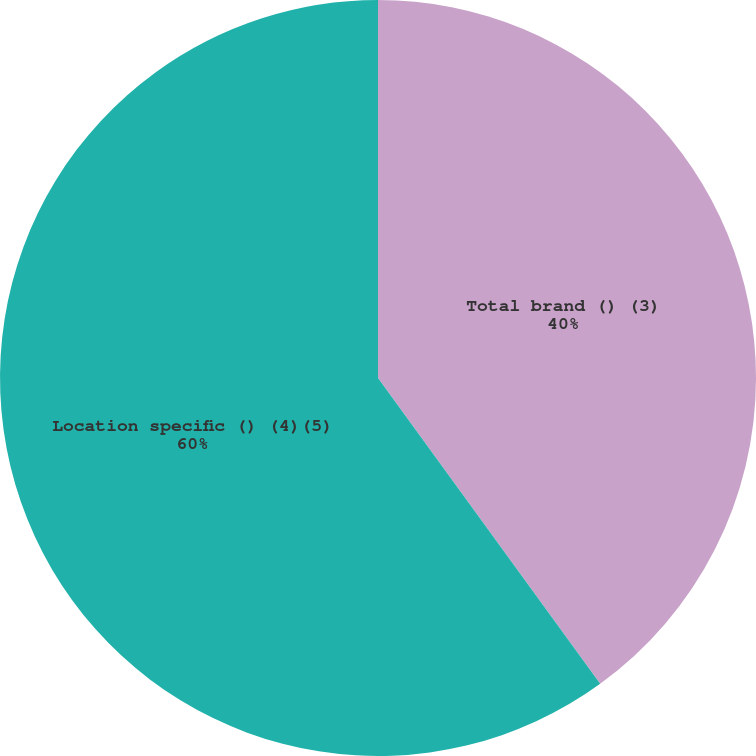Convert chart. <chart><loc_0><loc_0><loc_500><loc_500><pie_chart><fcel>Total brand () (3)<fcel>Location specific () (4)(5)<nl><fcel>40.0%<fcel>60.0%<nl></chart> 